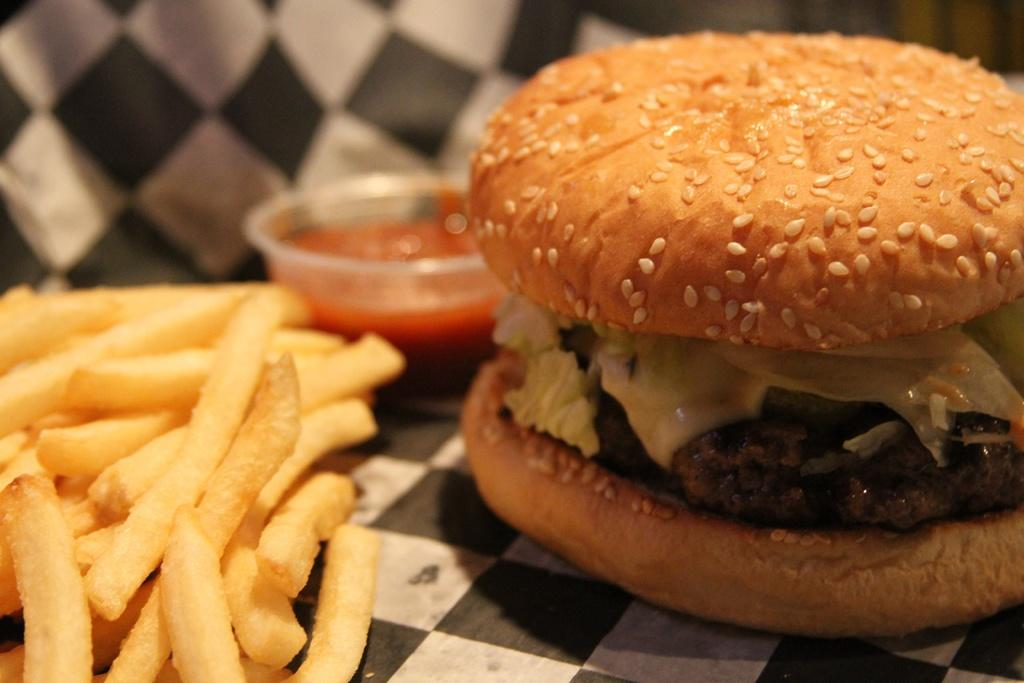What type of food is the main subject of the image? There is a burger in the image. What side dish is present in the image? There are french fries in the image. What condiment is visible in the image? There is sauce in the image. What type of holiday is being celebrated in the image? There is no indication of a holiday being celebrated in the image; it features a burger, french fries, and sauce. What topic is being discussed in the image? There is no discussion taking place in the image; it is a still image of food. 